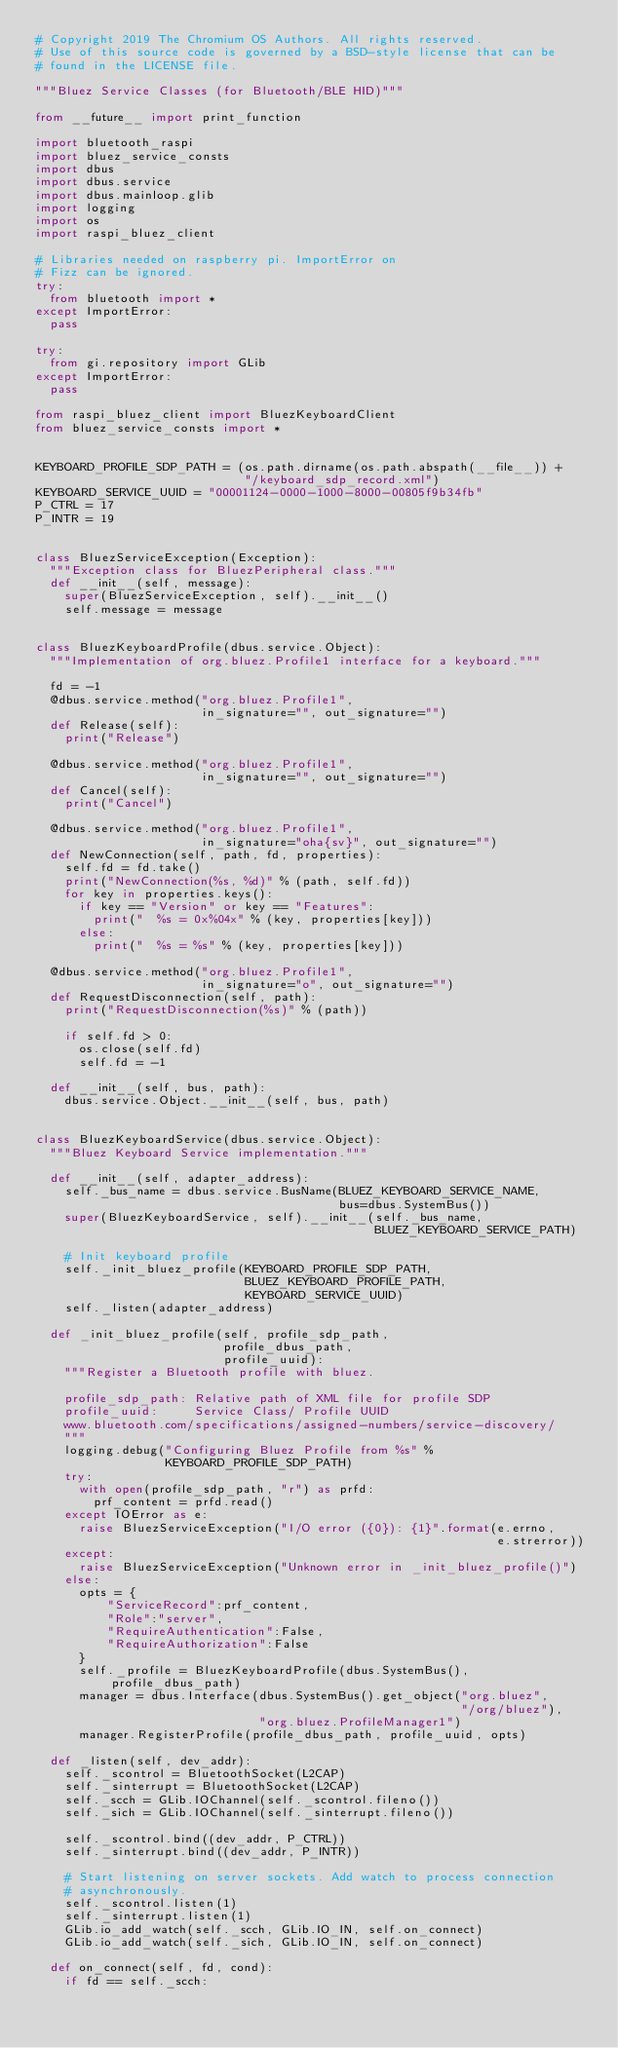Convert code to text. <code><loc_0><loc_0><loc_500><loc_500><_Python_># Copyright 2019 The Chromium OS Authors. All rights reserved.
# Use of this source code is governed by a BSD-style license that can be
# found in the LICENSE file.

"""Bluez Service Classes (for Bluetooth/BLE HID)"""

from __future__ import print_function

import bluetooth_raspi
import bluez_service_consts
import dbus
import dbus.service
import dbus.mainloop.glib
import logging
import os
import raspi_bluez_client

# Libraries needed on raspberry pi. ImportError on
# Fizz can be ignored.
try:
  from bluetooth import *
except ImportError:
  pass

try:
  from gi.repository import GLib
except ImportError:
  pass

from raspi_bluez_client import BluezKeyboardClient
from bluez_service_consts import *


KEYBOARD_PROFILE_SDP_PATH = (os.path.dirname(os.path.abspath(__file__)) +
                             "/keyboard_sdp_record.xml")
KEYBOARD_SERVICE_UUID = "00001124-0000-1000-8000-00805f9b34fb"
P_CTRL = 17
P_INTR = 19


class BluezServiceException(Exception):
  """Exception class for BluezPeripheral class."""
  def __init__(self, message):
    super(BluezServiceException, self).__init__()
    self.message = message


class BluezKeyboardProfile(dbus.service.Object):
  """Implementation of org.bluez.Profile1 interface for a keyboard."""

  fd = -1
  @dbus.service.method("org.bluez.Profile1",
                       in_signature="", out_signature="")
  def Release(self):
    print("Release")

  @dbus.service.method("org.bluez.Profile1",
                       in_signature="", out_signature="")
  def Cancel(self):
    print("Cancel")

  @dbus.service.method("org.bluez.Profile1",
                       in_signature="oha{sv}", out_signature="")
  def NewConnection(self, path, fd, properties):
    self.fd = fd.take()
    print("NewConnection(%s, %d)" % (path, self.fd))
    for key in properties.keys():
      if key == "Version" or key == "Features":
        print("  %s = 0x%04x" % (key, properties[key]))
      else:
        print("  %s = %s" % (key, properties[key]))

  @dbus.service.method("org.bluez.Profile1",
                       in_signature="o", out_signature="")
  def RequestDisconnection(self, path):
    print("RequestDisconnection(%s)" % (path))

    if self.fd > 0:
      os.close(self.fd)
      self.fd = -1

  def __init__(self, bus, path):
    dbus.service.Object.__init__(self, bus, path)


class BluezKeyboardService(dbus.service.Object):
  """Bluez Keyboard Service implementation."""

  def __init__(self, adapter_address):
    self._bus_name = dbus.service.BusName(BLUEZ_KEYBOARD_SERVICE_NAME,
                                          bus=dbus.SystemBus())
    super(BluezKeyboardService, self).__init__(self._bus_name,
                                               BLUEZ_KEYBOARD_SERVICE_PATH)

    # Init keyboard profile
    self._init_bluez_profile(KEYBOARD_PROFILE_SDP_PATH,
                             BLUEZ_KEYBOARD_PROFILE_PATH,
                             KEYBOARD_SERVICE_UUID)
    self._listen(adapter_address)

  def _init_bluez_profile(self, profile_sdp_path,
                          profile_dbus_path,
                          profile_uuid):
    """Register a Bluetooth profile with bluez.

    profile_sdp_path: Relative path of XML file for profile SDP
    profile_uuid:     Service Class/ Profile UUID
    www.bluetooth.com/specifications/assigned-numbers/service-discovery/
    """
    logging.debug("Configuring Bluez Profile from %s" %
                  KEYBOARD_PROFILE_SDP_PATH)
    try:
      with open(profile_sdp_path, "r") as prfd:
        prf_content = prfd.read()
    except IOError as e:
      raise BluezServiceException("I/O error ({0}): {1}".format(e.errno,
                                                                e.strerror))
    except:
      raise BluezServiceException("Unknown error in _init_bluez_profile()")
    else:
      opts = {
          "ServiceRecord":prf_content,
          "Role":"server",
          "RequireAuthentication":False,
          "RequireAuthorization":False
      }
      self._profile = BluezKeyboardProfile(dbus.SystemBus(), profile_dbus_path)
      manager = dbus.Interface(dbus.SystemBus().get_object("org.bluez",
                                                           "/org/bluez"),
                               "org.bluez.ProfileManager1")
      manager.RegisterProfile(profile_dbus_path, profile_uuid, opts)

  def _listen(self, dev_addr):
    self._scontrol = BluetoothSocket(L2CAP)
    self._sinterrupt = BluetoothSocket(L2CAP)
    self._scch = GLib.IOChannel(self._scontrol.fileno())
    self._sich = GLib.IOChannel(self._sinterrupt.fileno())

    self._scontrol.bind((dev_addr, P_CTRL))
    self._sinterrupt.bind((dev_addr, P_INTR))

    # Start listening on server sockets. Add watch to process connection
    # asynchronously.
    self._scontrol.listen(1)
    self._sinterrupt.listen(1)
    GLib.io_add_watch(self._scch, GLib.IO_IN, self.on_connect)
    GLib.io_add_watch(self._sich, GLib.IO_IN, self.on_connect)

  def on_connect(self, fd, cond):
    if fd == self._scch:</code> 